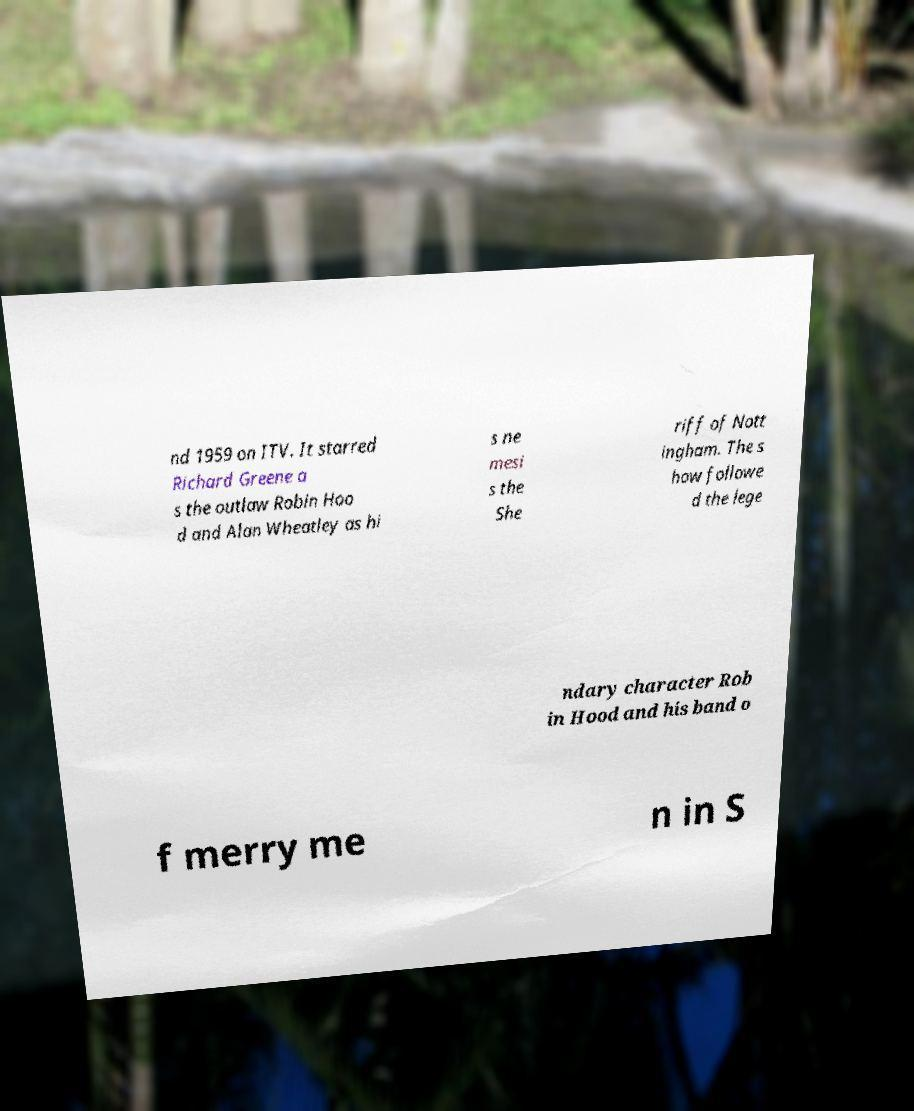Please identify and transcribe the text found in this image. nd 1959 on ITV. It starred Richard Greene a s the outlaw Robin Hoo d and Alan Wheatley as hi s ne mesi s the She riff of Nott ingham. The s how followe d the lege ndary character Rob in Hood and his band o f merry me n in S 